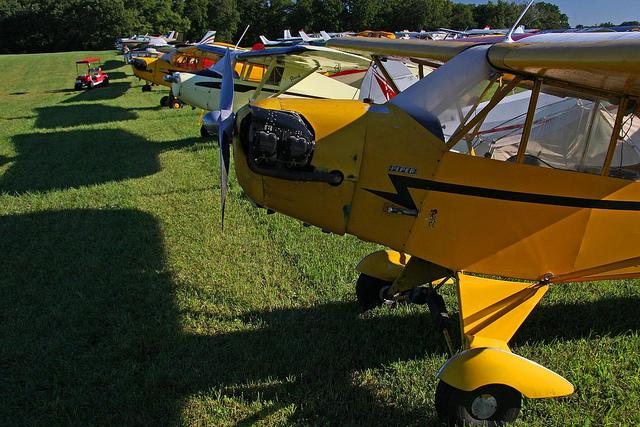Where are the planes?
Be succinct. On grass. How many planes are there?
Concise answer only. 5. What is in the picture?
Write a very short answer. Planes. 